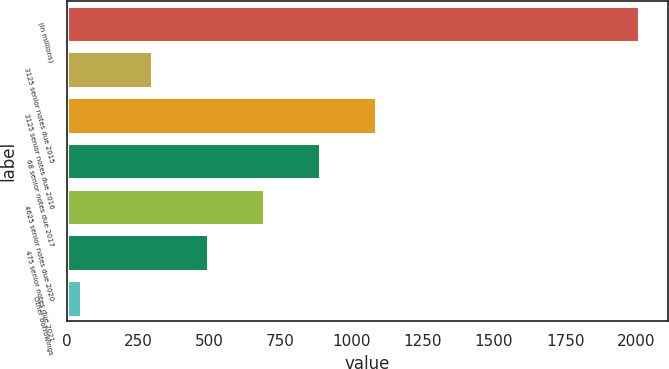Convert chart to OTSL. <chart><loc_0><loc_0><loc_500><loc_500><bar_chart><fcel>(In millions)<fcel>3125 senior notes due 2015<fcel>3125 senior notes due 2016<fcel>68 senior notes due 2017<fcel>4625 senior notes due 2020<fcel>475 senior notes due 2021<fcel>Other borrowings<nl><fcel>2011<fcel>299<fcel>1083.8<fcel>887.6<fcel>691.4<fcel>495.2<fcel>49<nl></chart> 